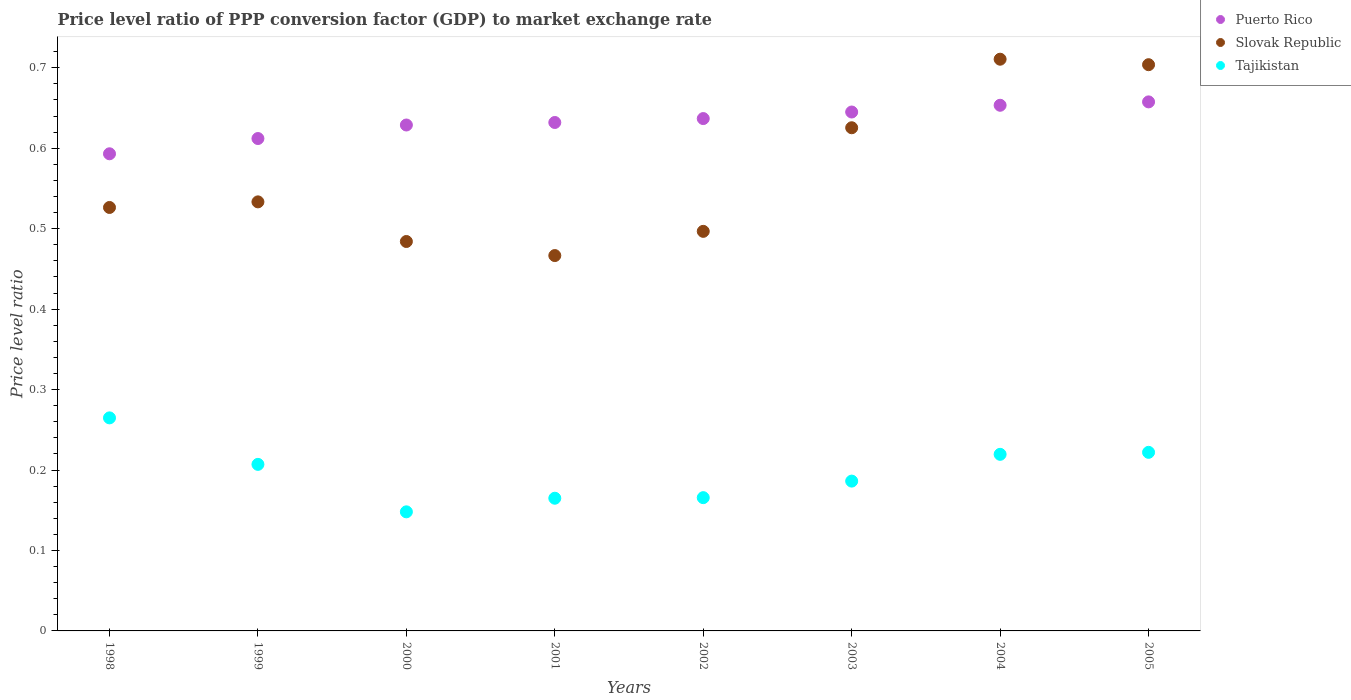What is the price level ratio in Puerto Rico in 1998?
Offer a very short reply. 0.59. Across all years, what is the maximum price level ratio in Tajikistan?
Your answer should be very brief. 0.26. Across all years, what is the minimum price level ratio in Slovak Republic?
Provide a short and direct response. 0.47. In which year was the price level ratio in Slovak Republic maximum?
Keep it short and to the point. 2004. What is the total price level ratio in Tajikistan in the graph?
Your response must be concise. 1.58. What is the difference between the price level ratio in Tajikistan in 1999 and that in 2000?
Offer a terse response. 0.06. What is the difference between the price level ratio in Slovak Republic in 2000 and the price level ratio in Puerto Rico in 2001?
Offer a terse response. -0.15. What is the average price level ratio in Puerto Rico per year?
Offer a terse response. 0.63. In the year 2001, what is the difference between the price level ratio in Puerto Rico and price level ratio in Slovak Republic?
Your answer should be very brief. 0.17. What is the ratio of the price level ratio in Puerto Rico in 2002 to that in 2003?
Your answer should be very brief. 0.99. Is the price level ratio in Slovak Republic in 1999 less than that in 2000?
Make the answer very short. No. What is the difference between the highest and the second highest price level ratio in Slovak Republic?
Offer a very short reply. 0.01. What is the difference between the highest and the lowest price level ratio in Puerto Rico?
Your answer should be very brief. 0.06. In how many years, is the price level ratio in Slovak Republic greater than the average price level ratio in Slovak Republic taken over all years?
Your answer should be compact. 3. Is the sum of the price level ratio in Puerto Rico in 1998 and 2001 greater than the maximum price level ratio in Slovak Republic across all years?
Make the answer very short. Yes. Is it the case that in every year, the sum of the price level ratio in Slovak Republic and price level ratio in Tajikistan  is greater than the price level ratio in Puerto Rico?
Offer a terse response. No. Does the price level ratio in Puerto Rico monotonically increase over the years?
Your answer should be compact. Yes. What is the difference between two consecutive major ticks on the Y-axis?
Provide a short and direct response. 0.1. How many legend labels are there?
Keep it short and to the point. 3. What is the title of the graph?
Keep it short and to the point. Price level ratio of PPP conversion factor (GDP) to market exchange rate. What is the label or title of the X-axis?
Provide a succinct answer. Years. What is the label or title of the Y-axis?
Provide a short and direct response. Price level ratio. What is the Price level ratio of Puerto Rico in 1998?
Give a very brief answer. 0.59. What is the Price level ratio of Slovak Republic in 1998?
Provide a succinct answer. 0.53. What is the Price level ratio of Tajikistan in 1998?
Your answer should be compact. 0.26. What is the Price level ratio of Puerto Rico in 1999?
Provide a short and direct response. 0.61. What is the Price level ratio of Slovak Republic in 1999?
Your response must be concise. 0.53. What is the Price level ratio of Tajikistan in 1999?
Keep it short and to the point. 0.21. What is the Price level ratio in Puerto Rico in 2000?
Keep it short and to the point. 0.63. What is the Price level ratio in Slovak Republic in 2000?
Offer a terse response. 0.48. What is the Price level ratio of Tajikistan in 2000?
Your answer should be compact. 0.15. What is the Price level ratio of Puerto Rico in 2001?
Provide a short and direct response. 0.63. What is the Price level ratio in Slovak Republic in 2001?
Give a very brief answer. 0.47. What is the Price level ratio in Tajikistan in 2001?
Provide a short and direct response. 0.16. What is the Price level ratio in Puerto Rico in 2002?
Make the answer very short. 0.64. What is the Price level ratio in Slovak Republic in 2002?
Provide a succinct answer. 0.5. What is the Price level ratio in Tajikistan in 2002?
Keep it short and to the point. 0.17. What is the Price level ratio in Puerto Rico in 2003?
Offer a terse response. 0.65. What is the Price level ratio of Slovak Republic in 2003?
Give a very brief answer. 0.63. What is the Price level ratio of Tajikistan in 2003?
Keep it short and to the point. 0.19. What is the Price level ratio of Puerto Rico in 2004?
Keep it short and to the point. 0.65. What is the Price level ratio in Slovak Republic in 2004?
Provide a short and direct response. 0.71. What is the Price level ratio of Tajikistan in 2004?
Your response must be concise. 0.22. What is the Price level ratio of Puerto Rico in 2005?
Offer a terse response. 0.66. What is the Price level ratio of Slovak Republic in 2005?
Provide a succinct answer. 0.7. What is the Price level ratio in Tajikistan in 2005?
Your response must be concise. 0.22. Across all years, what is the maximum Price level ratio of Puerto Rico?
Ensure brevity in your answer.  0.66. Across all years, what is the maximum Price level ratio in Slovak Republic?
Offer a terse response. 0.71. Across all years, what is the maximum Price level ratio in Tajikistan?
Your answer should be compact. 0.26. Across all years, what is the minimum Price level ratio of Puerto Rico?
Provide a short and direct response. 0.59. Across all years, what is the minimum Price level ratio of Slovak Republic?
Keep it short and to the point. 0.47. Across all years, what is the minimum Price level ratio in Tajikistan?
Offer a very short reply. 0.15. What is the total Price level ratio of Puerto Rico in the graph?
Offer a terse response. 5.06. What is the total Price level ratio of Slovak Republic in the graph?
Provide a succinct answer. 4.55. What is the total Price level ratio in Tajikistan in the graph?
Make the answer very short. 1.58. What is the difference between the Price level ratio of Puerto Rico in 1998 and that in 1999?
Provide a succinct answer. -0.02. What is the difference between the Price level ratio in Slovak Republic in 1998 and that in 1999?
Give a very brief answer. -0.01. What is the difference between the Price level ratio of Tajikistan in 1998 and that in 1999?
Ensure brevity in your answer.  0.06. What is the difference between the Price level ratio in Puerto Rico in 1998 and that in 2000?
Your answer should be very brief. -0.04. What is the difference between the Price level ratio of Slovak Republic in 1998 and that in 2000?
Your answer should be very brief. 0.04. What is the difference between the Price level ratio of Tajikistan in 1998 and that in 2000?
Ensure brevity in your answer.  0.12. What is the difference between the Price level ratio in Puerto Rico in 1998 and that in 2001?
Your response must be concise. -0.04. What is the difference between the Price level ratio in Slovak Republic in 1998 and that in 2001?
Ensure brevity in your answer.  0.06. What is the difference between the Price level ratio in Tajikistan in 1998 and that in 2001?
Make the answer very short. 0.1. What is the difference between the Price level ratio in Puerto Rico in 1998 and that in 2002?
Ensure brevity in your answer.  -0.04. What is the difference between the Price level ratio of Slovak Republic in 1998 and that in 2002?
Provide a short and direct response. 0.03. What is the difference between the Price level ratio of Tajikistan in 1998 and that in 2002?
Offer a terse response. 0.1. What is the difference between the Price level ratio of Puerto Rico in 1998 and that in 2003?
Offer a terse response. -0.05. What is the difference between the Price level ratio of Slovak Republic in 1998 and that in 2003?
Offer a very short reply. -0.1. What is the difference between the Price level ratio of Tajikistan in 1998 and that in 2003?
Give a very brief answer. 0.08. What is the difference between the Price level ratio in Puerto Rico in 1998 and that in 2004?
Make the answer very short. -0.06. What is the difference between the Price level ratio in Slovak Republic in 1998 and that in 2004?
Provide a short and direct response. -0.18. What is the difference between the Price level ratio of Tajikistan in 1998 and that in 2004?
Make the answer very short. 0.05. What is the difference between the Price level ratio of Puerto Rico in 1998 and that in 2005?
Your answer should be very brief. -0.06. What is the difference between the Price level ratio in Slovak Republic in 1998 and that in 2005?
Offer a terse response. -0.18. What is the difference between the Price level ratio in Tajikistan in 1998 and that in 2005?
Your answer should be very brief. 0.04. What is the difference between the Price level ratio of Puerto Rico in 1999 and that in 2000?
Provide a short and direct response. -0.02. What is the difference between the Price level ratio in Slovak Republic in 1999 and that in 2000?
Ensure brevity in your answer.  0.05. What is the difference between the Price level ratio in Tajikistan in 1999 and that in 2000?
Provide a short and direct response. 0.06. What is the difference between the Price level ratio in Puerto Rico in 1999 and that in 2001?
Your response must be concise. -0.02. What is the difference between the Price level ratio of Slovak Republic in 1999 and that in 2001?
Ensure brevity in your answer.  0.07. What is the difference between the Price level ratio in Tajikistan in 1999 and that in 2001?
Your response must be concise. 0.04. What is the difference between the Price level ratio in Puerto Rico in 1999 and that in 2002?
Offer a very short reply. -0.02. What is the difference between the Price level ratio of Slovak Republic in 1999 and that in 2002?
Your response must be concise. 0.04. What is the difference between the Price level ratio in Tajikistan in 1999 and that in 2002?
Your answer should be very brief. 0.04. What is the difference between the Price level ratio in Puerto Rico in 1999 and that in 2003?
Give a very brief answer. -0.03. What is the difference between the Price level ratio in Slovak Republic in 1999 and that in 2003?
Your response must be concise. -0.09. What is the difference between the Price level ratio of Tajikistan in 1999 and that in 2003?
Ensure brevity in your answer.  0.02. What is the difference between the Price level ratio of Puerto Rico in 1999 and that in 2004?
Make the answer very short. -0.04. What is the difference between the Price level ratio of Slovak Republic in 1999 and that in 2004?
Offer a very short reply. -0.18. What is the difference between the Price level ratio of Tajikistan in 1999 and that in 2004?
Make the answer very short. -0.01. What is the difference between the Price level ratio in Puerto Rico in 1999 and that in 2005?
Offer a very short reply. -0.05. What is the difference between the Price level ratio in Slovak Republic in 1999 and that in 2005?
Your answer should be very brief. -0.17. What is the difference between the Price level ratio of Tajikistan in 1999 and that in 2005?
Ensure brevity in your answer.  -0.01. What is the difference between the Price level ratio in Puerto Rico in 2000 and that in 2001?
Provide a short and direct response. -0. What is the difference between the Price level ratio of Slovak Republic in 2000 and that in 2001?
Your answer should be very brief. 0.02. What is the difference between the Price level ratio in Tajikistan in 2000 and that in 2001?
Provide a short and direct response. -0.02. What is the difference between the Price level ratio of Puerto Rico in 2000 and that in 2002?
Your answer should be compact. -0.01. What is the difference between the Price level ratio in Slovak Republic in 2000 and that in 2002?
Provide a short and direct response. -0.01. What is the difference between the Price level ratio in Tajikistan in 2000 and that in 2002?
Make the answer very short. -0.02. What is the difference between the Price level ratio of Puerto Rico in 2000 and that in 2003?
Keep it short and to the point. -0.02. What is the difference between the Price level ratio of Slovak Republic in 2000 and that in 2003?
Provide a succinct answer. -0.14. What is the difference between the Price level ratio in Tajikistan in 2000 and that in 2003?
Provide a short and direct response. -0.04. What is the difference between the Price level ratio in Puerto Rico in 2000 and that in 2004?
Your answer should be compact. -0.02. What is the difference between the Price level ratio in Slovak Republic in 2000 and that in 2004?
Your response must be concise. -0.23. What is the difference between the Price level ratio of Tajikistan in 2000 and that in 2004?
Give a very brief answer. -0.07. What is the difference between the Price level ratio of Puerto Rico in 2000 and that in 2005?
Make the answer very short. -0.03. What is the difference between the Price level ratio in Slovak Republic in 2000 and that in 2005?
Offer a very short reply. -0.22. What is the difference between the Price level ratio of Tajikistan in 2000 and that in 2005?
Your answer should be very brief. -0.07. What is the difference between the Price level ratio of Puerto Rico in 2001 and that in 2002?
Your response must be concise. -0. What is the difference between the Price level ratio in Slovak Republic in 2001 and that in 2002?
Provide a short and direct response. -0.03. What is the difference between the Price level ratio in Tajikistan in 2001 and that in 2002?
Your answer should be very brief. -0. What is the difference between the Price level ratio in Puerto Rico in 2001 and that in 2003?
Your response must be concise. -0.01. What is the difference between the Price level ratio of Slovak Republic in 2001 and that in 2003?
Offer a very short reply. -0.16. What is the difference between the Price level ratio in Tajikistan in 2001 and that in 2003?
Keep it short and to the point. -0.02. What is the difference between the Price level ratio in Puerto Rico in 2001 and that in 2004?
Give a very brief answer. -0.02. What is the difference between the Price level ratio of Slovak Republic in 2001 and that in 2004?
Keep it short and to the point. -0.24. What is the difference between the Price level ratio of Tajikistan in 2001 and that in 2004?
Keep it short and to the point. -0.05. What is the difference between the Price level ratio of Puerto Rico in 2001 and that in 2005?
Your answer should be very brief. -0.03. What is the difference between the Price level ratio of Slovak Republic in 2001 and that in 2005?
Provide a succinct answer. -0.24. What is the difference between the Price level ratio of Tajikistan in 2001 and that in 2005?
Ensure brevity in your answer.  -0.06. What is the difference between the Price level ratio in Puerto Rico in 2002 and that in 2003?
Offer a terse response. -0.01. What is the difference between the Price level ratio of Slovak Republic in 2002 and that in 2003?
Your response must be concise. -0.13. What is the difference between the Price level ratio in Tajikistan in 2002 and that in 2003?
Provide a short and direct response. -0.02. What is the difference between the Price level ratio of Puerto Rico in 2002 and that in 2004?
Ensure brevity in your answer.  -0.02. What is the difference between the Price level ratio in Slovak Republic in 2002 and that in 2004?
Your answer should be very brief. -0.21. What is the difference between the Price level ratio in Tajikistan in 2002 and that in 2004?
Your answer should be compact. -0.05. What is the difference between the Price level ratio of Puerto Rico in 2002 and that in 2005?
Provide a succinct answer. -0.02. What is the difference between the Price level ratio in Slovak Republic in 2002 and that in 2005?
Make the answer very short. -0.21. What is the difference between the Price level ratio of Tajikistan in 2002 and that in 2005?
Your answer should be compact. -0.06. What is the difference between the Price level ratio of Puerto Rico in 2003 and that in 2004?
Offer a terse response. -0.01. What is the difference between the Price level ratio of Slovak Republic in 2003 and that in 2004?
Provide a succinct answer. -0.09. What is the difference between the Price level ratio in Tajikistan in 2003 and that in 2004?
Keep it short and to the point. -0.03. What is the difference between the Price level ratio of Puerto Rico in 2003 and that in 2005?
Make the answer very short. -0.01. What is the difference between the Price level ratio in Slovak Republic in 2003 and that in 2005?
Ensure brevity in your answer.  -0.08. What is the difference between the Price level ratio of Tajikistan in 2003 and that in 2005?
Provide a short and direct response. -0.04. What is the difference between the Price level ratio in Puerto Rico in 2004 and that in 2005?
Ensure brevity in your answer.  -0. What is the difference between the Price level ratio of Slovak Republic in 2004 and that in 2005?
Offer a terse response. 0.01. What is the difference between the Price level ratio of Tajikistan in 2004 and that in 2005?
Your answer should be very brief. -0. What is the difference between the Price level ratio in Puerto Rico in 1998 and the Price level ratio in Slovak Republic in 1999?
Your response must be concise. 0.06. What is the difference between the Price level ratio of Puerto Rico in 1998 and the Price level ratio of Tajikistan in 1999?
Make the answer very short. 0.39. What is the difference between the Price level ratio of Slovak Republic in 1998 and the Price level ratio of Tajikistan in 1999?
Give a very brief answer. 0.32. What is the difference between the Price level ratio in Puerto Rico in 1998 and the Price level ratio in Slovak Republic in 2000?
Make the answer very short. 0.11. What is the difference between the Price level ratio in Puerto Rico in 1998 and the Price level ratio in Tajikistan in 2000?
Your answer should be compact. 0.45. What is the difference between the Price level ratio in Slovak Republic in 1998 and the Price level ratio in Tajikistan in 2000?
Your response must be concise. 0.38. What is the difference between the Price level ratio in Puerto Rico in 1998 and the Price level ratio in Slovak Republic in 2001?
Provide a short and direct response. 0.13. What is the difference between the Price level ratio of Puerto Rico in 1998 and the Price level ratio of Tajikistan in 2001?
Your response must be concise. 0.43. What is the difference between the Price level ratio in Slovak Republic in 1998 and the Price level ratio in Tajikistan in 2001?
Offer a very short reply. 0.36. What is the difference between the Price level ratio of Puerto Rico in 1998 and the Price level ratio of Slovak Republic in 2002?
Your response must be concise. 0.1. What is the difference between the Price level ratio in Puerto Rico in 1998 and the Price level ratio in Tajikistan in 2002?
Provide a short and direct response. 0.43. What is the difference between the Price level ratio of Slovak Republic in 1998 and the Price level ratio of Tajikistan in 2002?
Provide a short and direct response. 0.36. What is the difference between the Price level ratio of Puerto Rico in 1998 and the Price level ratio of Slovak Republic in 2003?
Make the answer very short. -0.03. What is the difference between the Price level ratio in Puerto Rico in 1998 and the Price level ratio in Tajikistan in 2003?
Provide a short and direct response. 0.41. What is the difference between the Price level ratio in Slovak Republic in 1998 and the Price level ratio in Tajikistan in 2003?
Your answer should be compact. 0.34. What is the difference between the Price level ratio of Puerto Rico in 1998 and the Price level ratio of Slovak Republic in 2004?
Your answer should be very brief. -0.12. What is the difference between the Price level ratio in Puerto Rico in 1998 and the Price level ratio in Tajikistan in 2004?
Offer a terse response. 0.37. What is the difference between the Price level ratio of Slovak Republic in 1998 and the Price level ratio of Tajikistan in 2004?
Offer a very short reply. 0.31. What is the difference between the Price level ratio of Puerto Rico in 1998 and the Price level ratio of Slovak Republic in 2005?
Provide a succinct answer. -0.11. What is the difference between the Price level ratio in Puerto Rico in 1998 and the Price level ratio in Tajikistan in 2005?
Your answer should be very brief. 0.37. What is the difference between the Price level ratio of Slovak Republic in 1998 and the Price level ratio of Tajikistan in 2005?
Ensure brevity in your answer.  0.3. What is the difference between the Price level ratio of Puerto Rico in 1999 and the Price level ratio of Slovak Republic in 2000?
Provide a succinct answer. 0.13. What is the difference between the Price level ratio of Puerto Rico in 1999 and the Price level ratio of Tajikistan in 2000?
Your answer should be compact. 0.46. What is the difference between the Price level ratio of Slovak Republic in 1999 and the Price level ratio of Tajikistan in 2000?
Your answer should be compact. 0.39. What is the difference between the Price level ratio of Puerto Rico in 1999 and the Price level ratio of Slovak Republic in 2001?
Ensure brevity in your answer.  0.15. What is the difference between the Price level ratio in Puerto Rico in 1999 and the Price level ratio in Tajikistan in 2001?
Offer a very short reply. 0.45. What is the difference between the Price level ratio of Slovak Republic in 1999 and the Price level ratio of Tajikistan in 2001?
Ensure brevity in your answer.  0.37. What is the difference between the Price level ratio of Puerto Rico in 1999 and the Price level ratio of Slovak Republic in 2002?
Your answer should be very brief. 0.12. What is the difference between the Price level ratio in Puerto Rico in 1999 and the Price level ratio in Tajikistan in 2002?
Make the answer very short. 0.45. What is the difference between the Price level ratio in Slovak Republic in 1999 and the Price level ratio in Tajikistan in 2002?
Your answer should be very brief. 0.37. What is the difference between the Price level ratio of Puerto Rico in 1999 and the Price level ratio of Slovak Republic in 2003?
Your answer should be compact. -0.01. What is the difference between the Price level ratio of Puerto Rico in 1999 and the Price level ratio of Tajikistan in 2003?
Offer a terse response. 0.43. What is the difference between the Price level ratio in Slovak Republic in 1999 and the Price level ratio in Tajikistan in 2003?
Offer a terse response. 0.35. What is the difference between the Price level ratio in Puerto Rico in 1999 and the Price level ratio in Slovak Republic in 2004?
Ensure brevity in your answer.  -0.1. What is the difference between the Price level ratio of Puerto Rico in 1999 and the Price level ratio of Tajikistan in 2004?
Ensure brevity in your answer.  0.39. What is the difference between the Price level ratio in Slovak Republic in 1999 and the Price level ratio in Tajikistan in 2004?
Your answer should be very brief. 0.31. What is the difference between the Price level ratio in Puerto Rico in 1999 and the Price level ratio in Slovak Republic in 2005?
Give a very brief answer. -0.09. What is the difference between the Price level ratio of Puerto Rico in 1999 and the Price level ratio of Tajikistan in 2005?
Offer a terse response. 0.39. What is the difference between the Price level ratio of Slovak Republic in 1999 and the Price level ratio of Tajikistan in 2005?
Your answer should be very brief. 0.31. What is the difference between the Price level ratio in Puerto Rico in 2000 and the Price level ratio in Slovak Republic in 2001?
Ensure brevity in your answer.  0.16. What is the difference between the Price level ratio in Puerto Rico in 2000 and the Price level ratio in Tajikistan in 2001?
Ensure brevity in your answer.  0.46. What is the difference between the Price level ratio of Slovak Republic in 2000 and the Price level ratio of Tajikistan in 2001?
Your answer should be very brief. 0.32. What is the difference between the Price level ratio of Puerto Rico in 2000 and the Price level ratio of Slovak Republic in 2002?
Your response must be concise. 0.13. What is the difference between the Price level ratio in Puerto Rico in 2000 and the Price level ratio in Tajikistan in 2002?
Offer a very short reply. 0.46. What is the difference between the Price level ratio in Slovak Republic in 2000 and the Price level ratio in Tajikistan in 2002?
Your answer should be very brief. 0.32. What is the difference between the Price level ratio in Puerto Rico in 2000 and the Price level ratio in Slovak Republic in 2003?
Make the answer very short. 0. What is the difference between the Price level ratio in Puerto Rico in 2000 and the Price level ratio in Tajikistan in 2003?
Keep it short and to the point. 0.44. What is the difference between the Price level ratio in Slovak Republic in 2000 and the Price level ratio in Tajikistan in 2003?
Keep it short and to the point. 0.3. What is the difference between the Price level ratio in Puerto Rico in 2000 and the Price level ratio in Slovak Republic in 2004?
Your response must be concise. -0.08. What is the difference between the Price level ratio of Puerto Rico in 2000 and the Price level ratio of Tajikistan in 2004?
Make the answer very short. 0.41. What is the difference between the Price level ratio of Slovak Republic in 2000 and the Price level ratio of Tajikistan in 2004?
Provide a short and direct response. 0.26. What is the difference between the Price level ratio in Puerto Rico in 2000 and the Price level ratio in Slovak Republic in 2005?
Provide a short and direct response. -0.07. What is the difference between the Price level ratio in Puerto Rico in 2000 and the Price level ratio in Tajikistan in 2005?
Offer a terse response. 0.41. What is the difference between the Price level ratio in Slovak Republic in 2000 and the Price level ratio in Tajikistan in 2005?
Offer a terse response. 0.26. What is the difference between the Price level ratio in Puerto Rico in 2001 and the Price level ratio in Slovak Republic in 2002?
Provide a succinct answer. 0.14. What is the difference between the Price level ratio of Puerto Rico in 2001 and the Price level ratio of Tajikistan in 2002?
Your answer should be compact. 0.47. What is the difference between the Price level ratio in Slovak Republic in 2001 and the Price level ratio in Tajikistan in 2002?
Keep it short and to the point. 0.3. What is the difference between the Price level ratio of Puerto Rico in 2001 and the Price level ratio of Slovak Republic in 2003?
Give a very brief answer. 0.01. What is the difference between the Price level ratio of Puerto Rico in 2001 and the Price level ratio of Tajikistan in 2003?
Provide a short and direct response. 0.45. What is the difference between the Price level ratio in Slovak Republic in 2001 and the Price level ratio in Tajikistan in 2003?
Your answer should be compact. 0.28. What is the difference between the Price level ratio of Puerto Rico in 2001 and the Price level ratio of Slovak Republic in 2004?
Your response must be concise. -0.08. What is the difference between the Price level ratio of Puerto Rico in 2001 and the Price level ratio of Tajikistan in 2004?
Your answer should be compact. 0.41. What is the difference between the Price level ratio of Slovak Republic in 2001 and the Price level ratio of Tajikistan in 2004?
Keep it short and to the point. 0.25. What is the difference between the Price level ratio in Puerto Rico in 2001 and the Price level ratio in Slovak Republic in 2005?
Make the answer very short. -0.07. What is the difference between the Price level ratio in Puerto Rico in 2001 and the Price level ratio in Tajikistan in 2005?
Your answer should be very brief. 0.41. What is the difference between the Price level ratio in Slovak Republic in 2001 and the Price level ratio in Tajikistan in 2005?
Keep it short and to the point. 0.24. What is the difference between the Price level ratio in Puerto Rico in 2002 and the Price level ratio in Slovak Republic in 2003?
Give a very brief answer. 0.01. What is the difference between the Price level ratio in Puerto Rico in 2002 and the Price level ratio in Tajikistan in 2003?
Make the answer very short. 0.45. What is the difference between the Price level ratio of Slovak Republic in 2002 and the Price level ratio of Tajikistan in 2003?
Provide a succinct answer. 0.31. What is the difference between the Price level ratio of Puerto Rico in 2002 and the Price level ratio of Slovak Republic in 2004?
Offer a very short reply. -0.07. What is the difference between the Price level ratio of Puerto Rico in 2002 and the Price level ratio of Tajikistan in 2004?
Provide a short and direct response. 0.42. What is the difference between the Price level ratio in Slovak Republic in 2002 and the Price level ratio in Tajikistan in 2004?
Your response must be concise. 0.28. What is the difference between the Price level ratio in Puerto Rico in 2002 and the Price level ratio in Slovak Republic in 2005?
Keep it short and to the point. -0.07. What is the difference between the Price level ratio of Puerto Rico in 2002 and the Price level ratio of Tajikistan in 2005?
Your answer should be compact. 0.41. What is the difference between the Price level ratio of Slovak Republic in 2002 and the Price level ratio of Tajikistan in 2005?
Offer a terse response. 0.27. What is the difference between the Price level ratio of Puerto Rico in 2003 and the Price level ratio of Slovak Republic in 2004?
Offer a terse response. -0.07. What is the difference between the Price level ratio of Puerto Rico in 2003 and the Price level ratio of Tajikistan in 2004?
Offer a very short reply. 0.43. What is the difference between the Price level ratio in Slovak Republic in 2003 and the Price level ratio in Tajikistan in 2004?
Your answer should be very brief. 0.41. What is the difference between the Price level ratio in Puerto Rico in 2003 and the Price level ratio in Slovak Republic in 2005?
Your answer should be very brief. -0.06. What is the difference between the Price level ratio in Puerto Rico in 2003 and the Price level ratio in Tajikistan in 2005?
Offer a very short reply. 0.42. What is the difference between the Price level ratio of Slovak Republic in 2003 and the Price level ratio of Tajikistan in 2005?
Provide a succinct answer. 0.4. What is the difference between the Price level ratio in Puerto Rico in 2004 and the Price level ratio in Slovak Republic in 2005?
Keep it short and to the point. -0.05. What is the difference between the Price level ratio in Puerto Rico in 2004 and the Price level ratio in Tajikistan in 2005?
Ensure brevity in your answer.  0.43. What is the difference between the Price level ratio in Slovak Republic in 2004 and the Price level ratio in Tajikistan in 2005?
Give a very brief answer. 0.49. What is the average Price level ratio in Puerto Rico per year?
Ensure brevity in your answer.  0.63. What is the average Price level ratio in Slovak Republic per year?
Your answer should be compact. 0.57. What is the average Price level ratio of Tajikistan per year?
Make the answer very short. 0.2. In the year 1998, what is the difference between the Price level ratio of Puerto Rico and Price level ratio of Slovak Republic?
Ensure brevity in your answer.  0.07. In the year 1998, what is the difference between the Price level ratio in Puerto Rico and Price level ratio in Tajikistan?
Your answer should be compact. 0.33. In the year 1998, what is the difference between the Price level ratio in Slovak Republic and Price level ratio in Tajikistan?
Make the answer very short. 0.26. In the year 1999, what is the difference between the Price level ratio of Puerto Rico and Price level ratio of Slovak Republic?
Keep it short and to the point. 0.08. In the year 1999, what is the difference between the Price level ratio in Puerto Rico and Price level ratio in Tajikistan?
Make the answer very short. 0.41. In the year 1999, what is the difference between the Price level ratio in Slovak Republic and Price level ratio in Tajikistan?
Keep it short and to the point. 0.33. In the year 2000, what is the difference between the Price level ratio in Puerto Rico and Price level ratio in Slovak Republic?
Your answer should be very brief. 0.14. In the year 2000, what is the difference between the Price level ratio of Puerto Rico and Price level ratio of Tajikistan?
Provide a short and direct response. 0.48. In the year 2000, what is the difference between the Price level ratio of Slovak Republic and Price level ratio of Tajikistan?
Give a very brief answer. 0.34. In the year 2001, what is the difference between the Price level ratio in Puerto Rico and Price level ratio in Slovak Republic?
Offer a very short reply. 0.17. In the year 2001, what is the difference between the Price level ratio of Puerto Rico and Price level ratio of Tajikistan?
Make the answer very short. 0.47. In the year 2001, what is the difference between the Price level ratio of Slovak Republic and Price level ratio of Tajikistan?
Provide a short and direct response. 0.3. In the year 2002, what is the difference between the Price level ratio in Puerto Rico and Price level ratio in Slovak Republic?
Your answer should be very brief. 0.14. In the year 2002, what is the difference between the Price level ratio of Puerto Rico and Price level ratio of Tajikistan?
Give a very brief answer. 0.47. In the year 2002, what is the difference between the Price level ratio of Slovak Republic and Price level ratio of Tajikistan?
Give a very brief answer. 0.33. In the year 2003, what is the difference between the Price level ratio of Puerto Rico and Price level ratio of Slovak Republic?
Provide a succinct answer. 0.02. In the year 2003, what is the difference between the Price level ratio in Puerto Rico and Price level ratio in Tajikistan?
Give a very brief answer. 0.46. In the year 2003, what is the difference between the Price level ratio in Slovak Republic and Price level ratio in Tajikistan?
Ensure brevity in your answer.  0.44. In the year 2004, what is the difference between the Price level ratio of Puerto Rico and Price level ratio of Slovak Republic?
Your response must be concise. -0.06. In the year 2004, what is the difference between the Price level ratio in Puerto Rico and Price level ratio in Tajikistan?
Offer a terse response. 0.43. In the year 2004, what is the difference between the Price level ratio of Slovak Republic and Price level ratio of Tajikistan?
Offer a very short reply. 0.49. In the year 2005, what is the difference between the Price level ratio in Puerto Rico and Price level ratio in Slovak Republic?
Your answer should be compact. -0.05. In the year 2005, what is the difference between the Price level ratio in Puerto Rico and Price level ratio in Tajikistan?
Provide a succinct answer. 0.44. In the year 2005, what is the difference between the Price level ratio in Slovak Republic and Price level ratio in Tajikistan?
Keep it short and to the point. 0.48. What is the ratio of the Price level ratio of Puerto Rico in 1998 to that in 1999?
Make the answer very short. 0.97. What is the ratio of the Price level ratio in Slovak Republic in 1998 to that in 1999?
Give a very brief answer. 0.99. What is the ratio of the Price level ratio in Tajikistan in 1998 to that in 1999?
Your response must be concise. 1.28. What is the ratio of the Price level ratio in Puerto Rico in 1998 to that in 2000?
Your answer should be compact. 0.94. What is the ratio of the Price level ratio of Slovak Republic in 1998 to that in 2000?
Give a very brief answer. 1.09. What is the ratio of the Price level ratio of Tajikistan in 1998 to that in 2000?
Your response must be concise. 1.79. What is the ratio of the Price level ratio in Puerto Rico in 1998 to that in 2001?
Make the answer very short. 0.94. What is the ratio of the Price level ratio of Slovak Republic in 1998 to that in 2001?
Ensure brevity in your answer.  1.13. What is the ratio of the Price level ratio of Tajikistan in 1998 to that in 2001?
Keep it short and to the point. 1.61. What is the ratio of the Price level ratio of Puerto Rico in 1998 to that in 2002?
Offer a terse response. 0.93. What is the ratio of the Price level ratio of Slovak Republic in 1998 to that in 2002?
Provide a short and direct response. 1.06. What is the ratio of the Price level ratio of Tajikistan in 1998 to that in 2002?
Your answer should be compact. 1.6. What is the ratio of the Price level ratio in Puerto Rico in 1998 to that in 2003?
Offer a terse response. 0.92. What is the ratio of the Price level ratio of Slovak Republic in 1998 to that in 2003?
Make the answer very short. 0.84. What is the ratio of the Price level ratio in Tajikistan in 1998 to that in 2003?
Your answer should be compact. 1.42. What is the ratio of the Price level ratio of Puerto Rico in 1998 to that in 2004?
Make the answer very short. 0.91. What is the ratio of the Price level ratio of Slovak Republic in 1998 to that in 2004?
Give a very brief answer. 0.74. What is the ratio of the Price level ratio of Tajikistan in 1998 to that in 2004?
Give a very brief answer. 1.21. What is the ratio of the Price level ratio in Puerto Rico in 1998 to that in 2005?
Offer a very short reply. 0.9. What is the ratio of the Price level ratio in Slovak Republic in 1998 to that in 2005?
Keep it short and to the point. 0.75. What is the ratio of the Price level ratio in Tajikistan in 1998 to that in 2005?
Offer a terse response. 1.19. What is the ratio of the Price level ratio of Puerto Rico in 1999 to that in 2000?
Provide a short and direct response. 0.97. What is the ratio of the Price level ratio of Slovak Republic in 1999 to that in 2000?
Keep it short and to the point. 1.1. What is the ratio of the Price level ratio of Tajikistan in 1999 to that in 2000?
Offer a terse response. 1.4. What is the ratio of the Price level ratio of Puerto Rico in 1999 to that in 2001?
Offer a very short reply. 0.97. What is the ratio of the Price level ratio in Slovak Republic in 1999 to that in 2001?
Give a very brief answer. 1.14. What is the ratio of the Price level ratio of Tajikistan in 1999 to that in 2001?
Keep it short and to the point. 1.26. What is the ratio of the Price level ratio of Puerto Rico in 1999 to that in 2002?
Keep it short and to the point. 0.96. What is the ratio of the Price level ratio in Slovak Republic in 1999 to that in 2002?
Ensure brevity in your answer.  1.07. What is the ratio of the Price level ratio in Tajikistan in 1999 to that in 2002?
Your answer should be compact. 1.25. What is the ratio of the Price level ratio in Puerto Rico in 1999 to that in 2003?
Keep it short and to the point. 0.95. What is the ratio of the Price level ratio of Slovak Republic in 1999 to that in 2003?
Give a very brief answer. 0.85. What is the ratio of the Price level ratio in Tajikistan in 1999 to that in 2003?
Give a very brief answer. 1.11. What is the ratio of the Price level ratio in Puerto Rico in 1999 to that in 2004?
Your response must be concise. 0.94. What is the ratio of the Price level ratio in Slovak Republic in 1999 to that in 2004?
Offer a terse response. 0.75. What is the ratio of the Price level ratio of Tajikistan in 1999 to that in 2004?
Make the answer very short. 0.94. What is the ratio of the Price level ratio in Puerto Rico in 1999 to that in 2005?
Ensure brevity in your answer.  0.93. What is the ratio of the Price level ratio in Slovak Republic in 1999 to that in 2005?
Make the answer very short. 0.76. What is the ratio of the Price level ratio in Tajikistan in 1999 to that in 2005?
Ensure brevity in your answer.  0.93. What is the ratio of the Price level ratio of Puerto Rico in 2000 to that in 2001?
Ensure brevity in your answer.  0.99. What is the ratio of the Price level ratio in Slovak Republic in 2000 to that in 2001?
Provide a short and direct response. 1.04. What is the ratio of the Price level ratio of Tajikistan in 2000 to that in 2001?
Keep it short and to the point. 0.9. What is the ratio of the Price level ratio of Puerto Rico in 2000 to that in 2002?
Keep it short and to the point. 0.99. What is the ratio of the Price level ratio of Slovak Republic in 2000 to that in 2002?
Offer a terse response. 0.97. What is the ratio of the Price level ratio in Tajikistan in 2000 to that in 2002?
Your response must be concise. 0.89. What is the ratio of the Price level ratio in Slovak Republic in 2000 to that in 2003?
Make the answer very short. 0.77. What is the ratio of the Price level ratio of Tajikistan in 2000 to that in 2003?
Provide a succinct answer. 0.79. What is the ratio of the Price level ratio in Puerto Rico in 2000 to that in 2004?
Give a very brief answer. 0.96. What is the ratio of the Price level ratio in Slovak Republic in 2000 to that in 2004?
Make the answer very short. 0.68. What is the ratio of the Price level ratio of Tajikistan in 2000 to that in 2004?
Provide a short and direct response. 0.67. What is the ratio of the Price level ratio in Puerto Rico in 2000 to that in 2005?
Provide a succinct answer. 0.96. What is the ratio of the Price level ratio in Slovak Republic in 2000 to that in 2005?
Offer a terse response. 0.69. What is the ratio of the Price level ratio of Tajikistan in 2000 to that in 2005?
Ensure brevity in your answer.  0.67. What is the ratio of the Price level ratio of Puerto Rico in 2001 to that in 2002?
Your answer should be very brief. 0.99. What is the ratio of the Price level ratio in Slovak Republic in 2001 to that in 2002?
Your response must be concise. 0.94. What is the ratio of the Price level ratio of Tajikistan in 2001 to that in 2002?
Your answer should be compact. 1. What is the ratio of the Price level ratio in Puerto Rico in 2001 to that in 2003?
Your answer should be compact. 0.98. What is the ratio of the Price level ratio of Slovak Republic in 2001 to that in 2003?
Your answer should be compact. 0.75. What is the ratio of the Price level ratio in Tajikistan in 2001 to that in 2003?
Offer a terse response. 0.89. What is the ratio of the Price level ratio of Puerto Rico in 2001 to that in 2004?
Offer a terse response. 0.97. What is the ratio of the Price level ratio in Slovak Republic in 2001 to that in 2004?
Provide a short and direct response. 0.66. What is the ratio of the Price level ratio of Tajikistan in 2001 to that in 2004?
Your answer should be compact. 0.75. What is the ratio of the Price level ratio in Puerto Rico in 2001 to that in 2005?
Your answer should be very brief. 0.96. What is the ratio of the Price level ratio in Slovak Republic in 2001 to that in 2005?
Offer a very short reply. 0.66. What is the ratio of the Price level ratio in Tajikistan in 2001 to that in 2005?
Keep it short and to the point. 0.74. What is the ratio of the Price level ratio in Puerto Rico in 2002 to that in 2003?
Your answer should be compact. 0.99. What is the ratio of the Price level ratio of Slovak Republic in 2002 to that in 2003?
Offer a terse response. 0.79. What is the ratio of the Price level ratio of Tajikistan in 2002 to that in 2003?
Make the answer very short. 0.89. What is the ratio of the Price level ratio of Puerto Rico in 2002 to that in 2004?
Your response must be concise. 0.97. What is the ratio of the Price level ratio in Slovak Republic in 2002 to that in 2004?
Your answer should be very brief. 0.7. What is the ratio of the Price level ratio of Tajikistan in 2002 to that in 2004?
Give a very brief answer. 0.75. What is the ratio of the Price level ratio of Puerto Rico in 2002 to that in 2005?
Your answer should be very brief. 0.97. What is the ratio of the Price level ratio of Slovak Republic in 2002 to that in 2005?
Keep it short and to the point. 0.71. What is the ratio of the Price level ratio of Tajikistan in 2002 to that in 2005?
Keep it short and to the point. 0.75. What is the ratio of the Price level ratio in Puerto Rico in 2003 to that in 2004?
Your answer should be very brief. 0.99. What is the ratio of the Price level ratio of Slovak Republic in 2003 to that in 2004?
Provide a succinct answer. 0.88. What is the ratio of the Price level ratio in Tajikistan in 2003 to that in 2004?
Keep it short and to the point. 0.85. What is the ratio of the Price level ratio of Puerto Rico in 2003 to that in 2005?
Your answer should be very brief. 0.98. What is the ratio of the Price level ratio of Slovak Republic in 2003 to that in 2005?
Offer a terse response. 0.89. What is the ratio of the Price level ratio of Tajikistan in 2003 to that in 2005?
Give a very brief answer. 0.84. What is the ratio of the Price level ratio in Slovak Republic in 2004 to that in 2005?
Your answer should be compact. 1.01. What is the ratio of the Price level ratio in Tajikistan in 2004 to that in 2005?
Offer a terse response. 0.99. What is the difference between the highest and the second highest Price level ratio in Puerto Rico?
Your response must be concise. 0. What is the difference between the highest and the second highest Price level ratio in Slovak Republic?
Make the answer very short. 0.01. What is the difference between the highest and the second highest Price level ratio in Tajikistan?
Offer a terse response. 0.04. What is the difference between the highest and the lowest Price level ratio in Puerto Rico?
Keep it short and to the point. 0.06. What is the difference between the highest and the lowest Price level ratio in Slovak Republic?
Your answer should be very brief. 0.24. What is the difference between the highest and the lowest Price level ratio of Tajikistan?
Give a very brief answer. 0.12. 